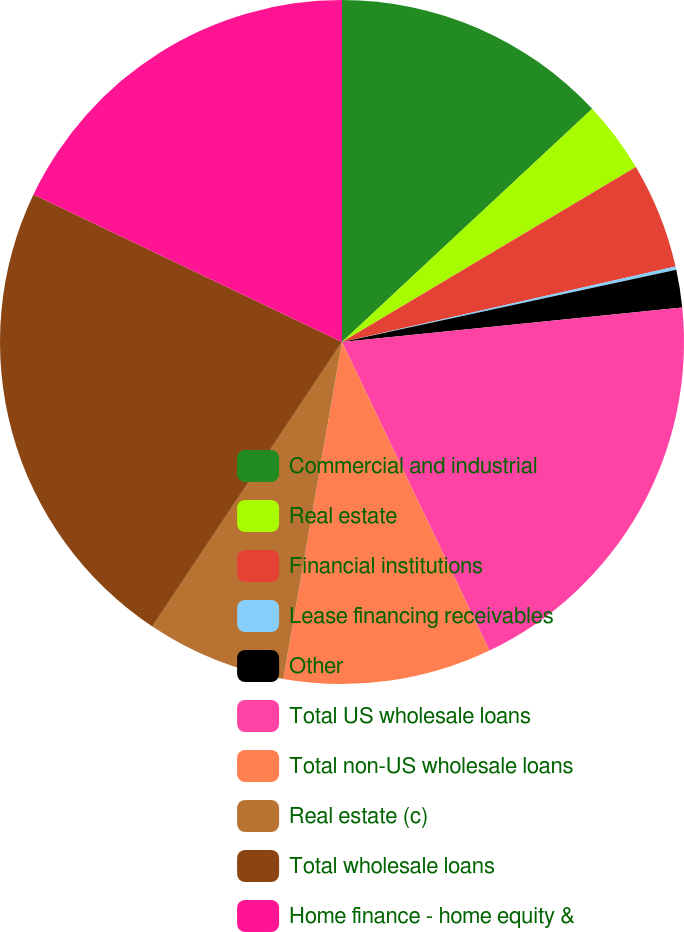Convert chart. <chart><loc_0><loc_0><loc_500><loc_500><pie_chart><fcel>Commercial and industrial<fcel>Real estate<fcel>Financial institutions<fcel>Lease financing receivables<fcel>Other<fcel>Total US wholesale loans<fcel>Total non-US wholesale loans<fcel>Real estate (c)<fcel>Total wholesale loans<fcel>Home finance - home equity &<nl><fcel>13.06%<fcel>3.39%<fcel>5.0%<fcel>0.16%<fcel>1.78%<fcel>19.51%<fcel>9.84%<fcel>6.61%<fcel>22.74%<fcel>17.9%<nl></chart> 